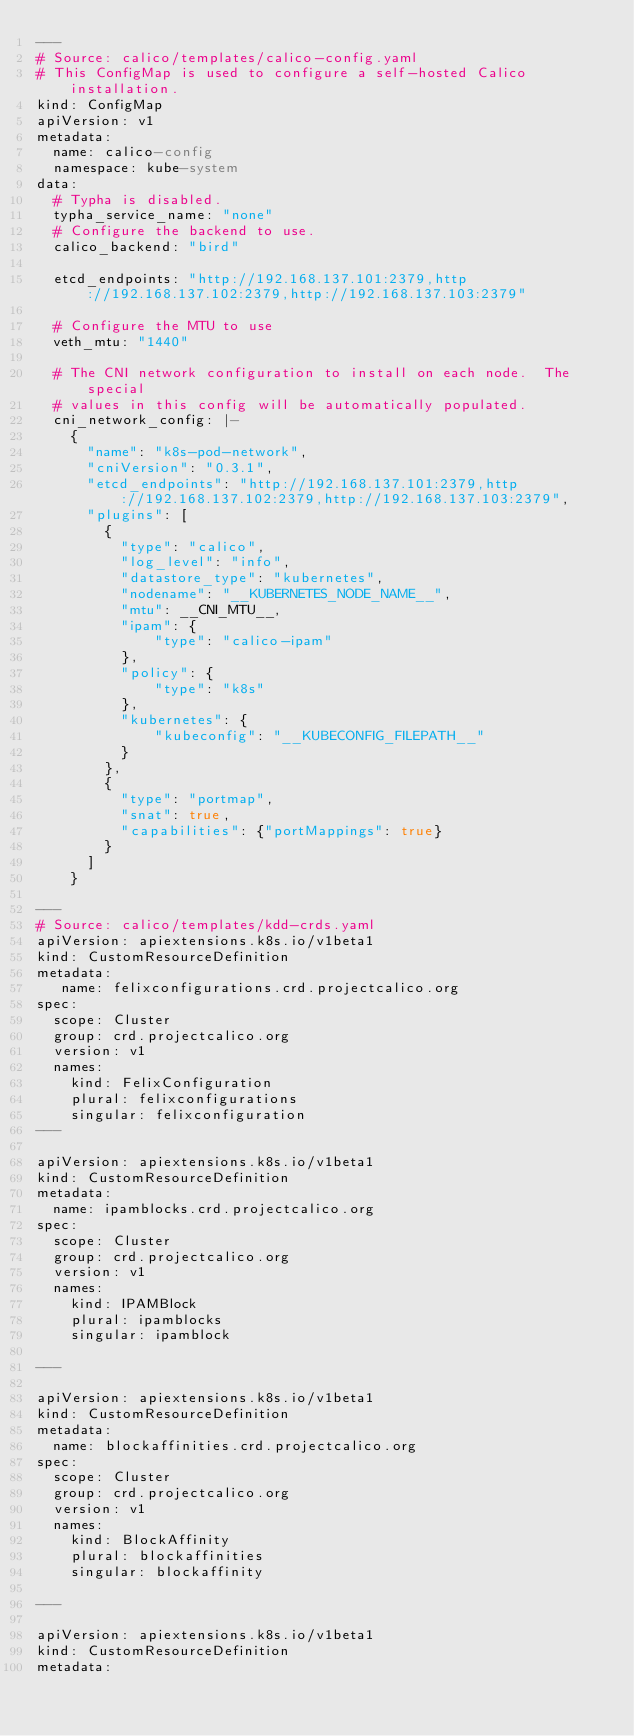<code> <loc_0><loc_0><loc_500><loc_500><_YAML_>---
# Source: calico/templates/calico-config.yaml
# This ConfigMap is used to configure a self-hosted Calico installation.
kind: ConfigMap
apiVersion: v1
metadata:
  name: calico-config
  namespace: kube-system
data:
  # Typha is disabled.
  typha_service_name: "none"
  # Configure the backend to use.
  calico_backend: "bird"

  etcd_endpoints: "http://192.168.137.101:2379,http://192.168.137.102:2379,http://192.168.137.103:2379"

  # Configure the MTU to use
  veth_mtu: "1440"

  # The CNI network configuration to install on each node.  The special
  # values in this config will be automatically populated.
  cni_network_config: |-
    {
      "name": "k8s-pod-network",
      "cniVersion": "0.3.1",
      "etcd_endpoints": "http://192.168.137.101:2379,http://192.168.137.102:2379,http://192.168.137.103:2379",
      "plugins": [
        {
          "type": "calico",
          "log_level": "info",
          "datastore_type": "kubernetes",
          "nodename": "__KUBERNETES_NODE_NAME__",
          "mtu": __CNI_MTU__,
          "ipam": {
              "type": "calico-ipam"
          },
          "policy": {
              "type": "k8s"
          },
          "kubernetes": {
              "kubeconfig": "__KUBECONFIG_FILEPATH__"
          }
        },
        {
          "type": "portmap",
          "snat": true,
          "capabilities": {"portMappings": true}
        }
      ]
    }

---
# Source: calico/templates/kdd-crds.yaml
apiVersion: apiextensions.k8s.io/v1beta1
kind: CustomResourceDefinition
metadata:
   name: felixconfigurations.crd.projectcalico.org
spec:
  scope: Cluster
  group: crd.projectcalico.org
  version: v1
  names:
    kind: FelixConfiguration
    plural: felixconfigurations
    singular: felixconfiguration
---

apiVersion: apiextensions.k8s.io/v1beta1
kind: CustomResourceDefinition
metadata:
  name: ipamblocks.crd.projectcalico.org
spec:
  scope: Cluster
  group: crd.projectcalico.org
  version: v1
  names:
    kind: IPAMBlock
    plural: ipamblocks
    singular: ipamblock

---

apiVersion: apiextensions.k8s.io/v1beta1
kind: CustomResourceDefinition
metadata:
  name: blockaffinities.crd.projectcalico.org
spec:
  scope: Cluster
  group: crd.projectcalico.org
  version: v1
  names:
    kind: BlockAffinity
    plural: blockaffinities
    singular: blockaffinity

---

apiVersion: apiextensions.k8s.io/v1beta1
kind: CustomResourceDefinition
metadata:</code> 